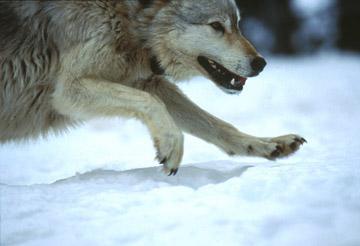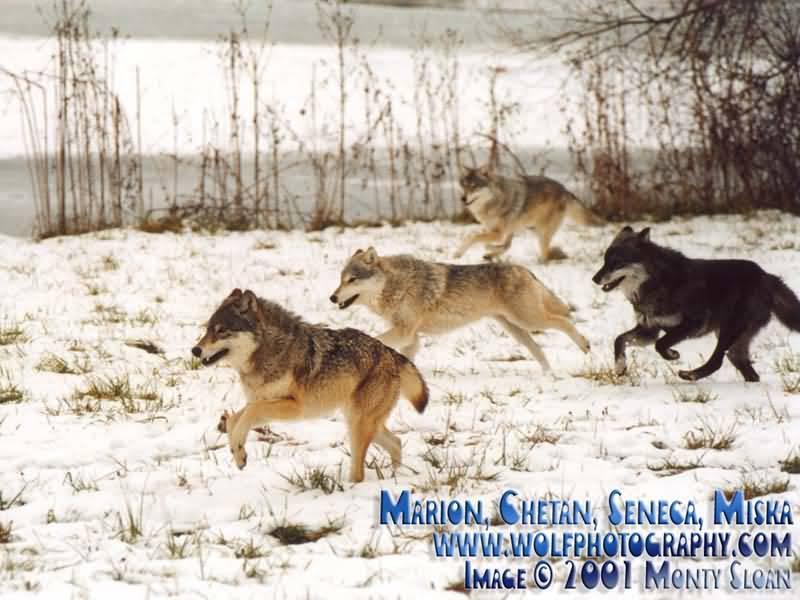The first image is the image on the left, the second image is the image on the right. For the images displayed, is the sentence "there are 5 wolves running in the snow in the image pair" factually correct? Answer yes or no. Yes. 